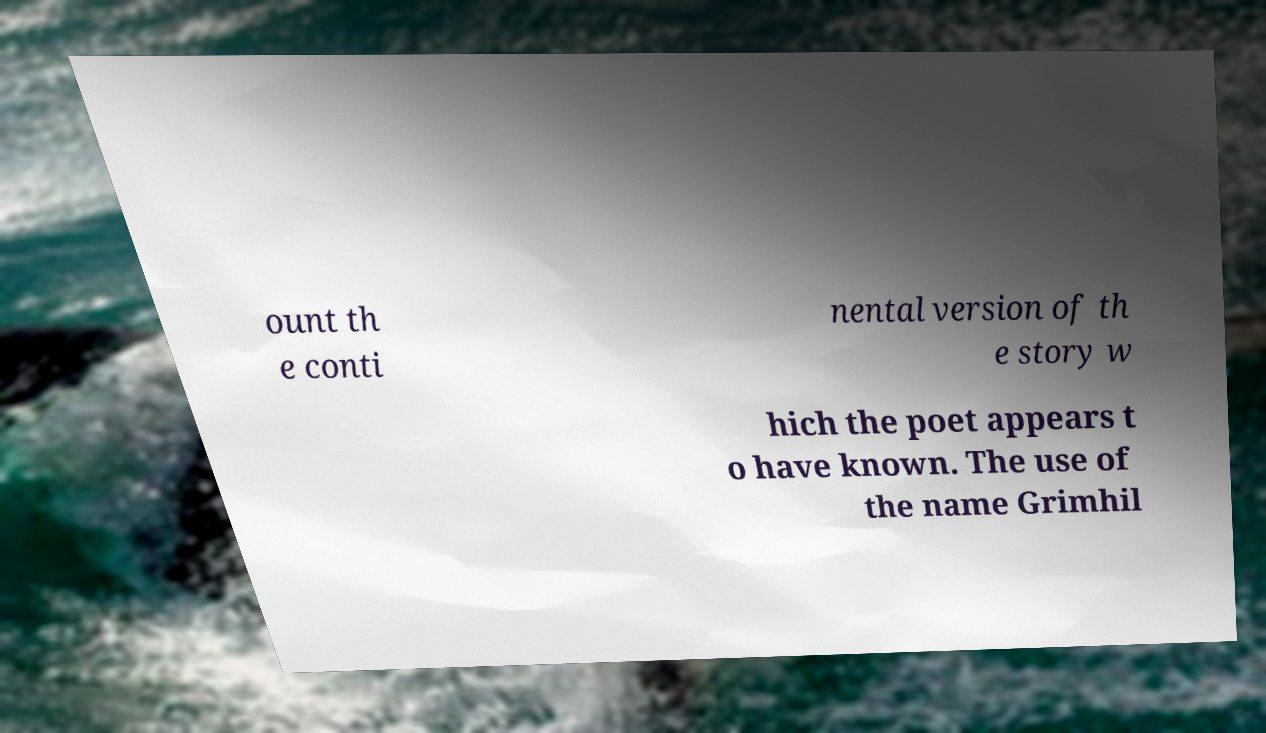Could you assist in decoding the text presented in this image and type it out clearly? ount th e conti nental version of th e story w hich the poet appears t o have known. The use of the name Grimhil 